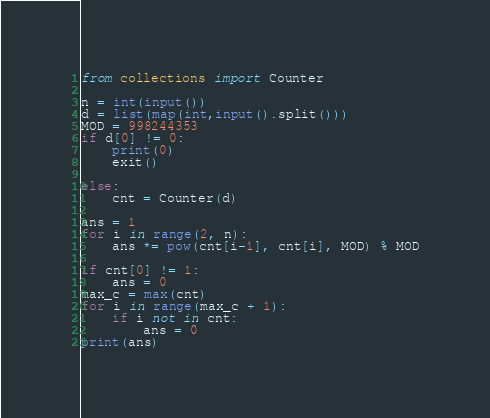<code> <loc_0><loc_0><loc_500><loc_500><_Python_>from collections import Counter

n = int(input())
d = list(map(int,input().split()))
MOD = 998244353
if d[0] != 0:
    print(0)
    exit()

else:
    cnt = Counter(d)

ans = 1
for i in range(2, n):
    ans *= pow(cnt[i-1], cnt[i], MOD) % MOD

if cnt[0] != 1:
    ans = 0
max_c = max(cnt)
for i in range(max_c + 1):
    if i not in cnt:
        ans = 0
print(ans)
</code> 